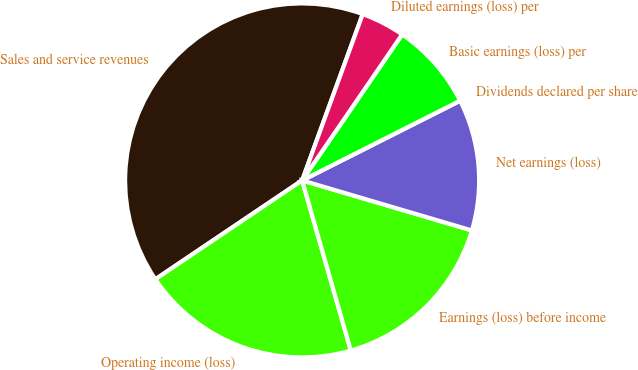<chart> <loc_0><loc_0><loc_500><loc_500><pie_chart><fcel>Sales and service revenues<fcel>Operating income (loss)<fcel>Earnings (loss) before income<fcel>Net earnings (loss)<fcel>Dividends declared per share<fcel>Basic earnings (loss) per<fcel>Diluted earnings (loss) per<nl><fcel>39.99%<fcel>20.0%<fcel>16.0%<fcel>12.0%<fcel>0.0%<fcel>8.0%<fcel>4.0%<nl></chart> 